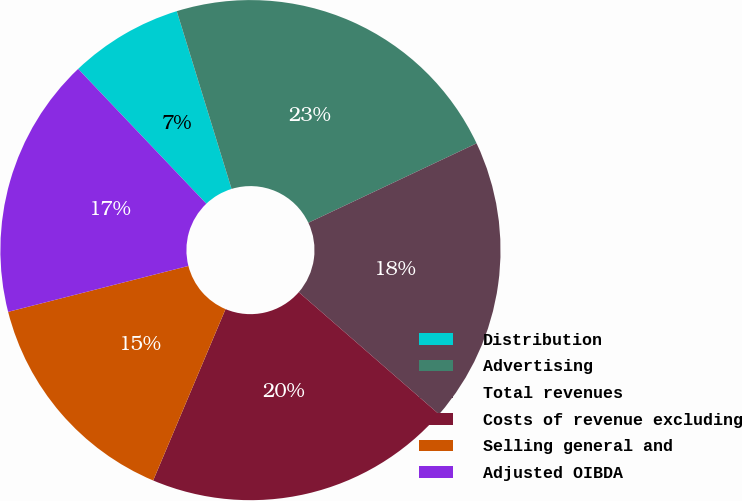<chart> <loc_0><loc_0><loc_500><loc_500><pie_chart><fcel>Distribution<fcel>Advertising<fcel>Total revenues<fcel>Costs of revenue excluding<fcel>Selling general and<fcel>Adjusted OIBDA<nl><fcel>7.34%<fcel>22.74%<fcel>18.42%<fcel>19.96%<fcel>14.67%<fcel>16.87%<nl></chart> 